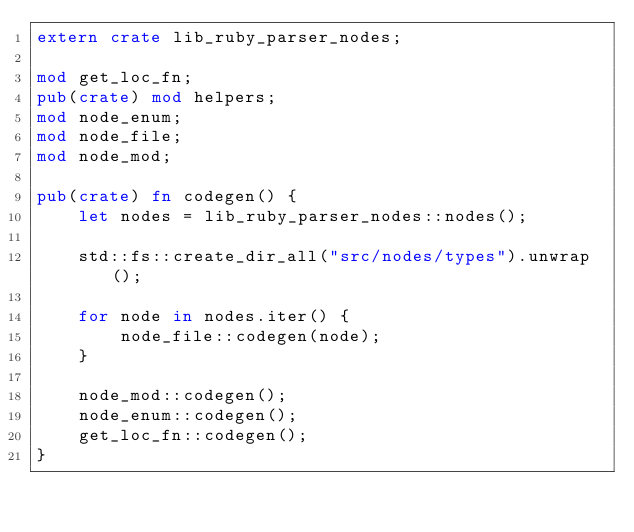Convert code to text. <code><loc_0><loc_0><loc_500><loc_500><_Rust_>extern crate lib_ruby_parser_nodes;

mod get_loc_fn;
pub(crate) mod helpers;
mod node_enum;
mod node_file;
mod node_mod;

pub(crate) fn codegen() {
    let nodes = lib_ruby_parser_nodes::nodes();

    std::fs::create_dir_all("src/nodes/types").unwrap();

    for node in nodes.iter() {
        node_file::codegen(node);
    }

    node_mod::codegen();
    node_enum::codegen();
    get_loc_fn::codegen();
}
</code> 